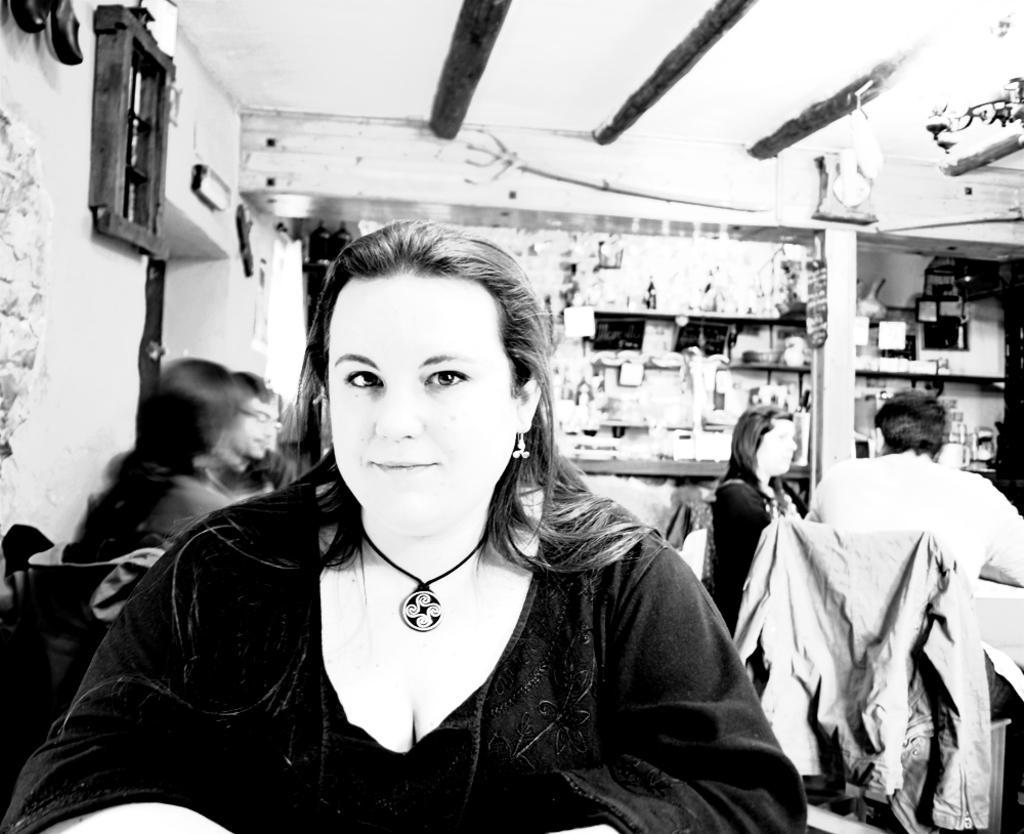Describe this image in one or two sentences. In this picture we can see few people, they are all sitting on the chairs, in the middle of the image we can see a woman, she is smiling, behind her we can see few things in the racks and it is a black and white photography. 